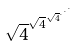<formula> <loc_0><loc_0><loc_500><loc_500>\sqrt { 4 } ^ { \sqrt { 4 } ^ { \sqrt { 4 } ^ { \cdot ^ { \cdot ^ { \cdot } } } } }</formula> 